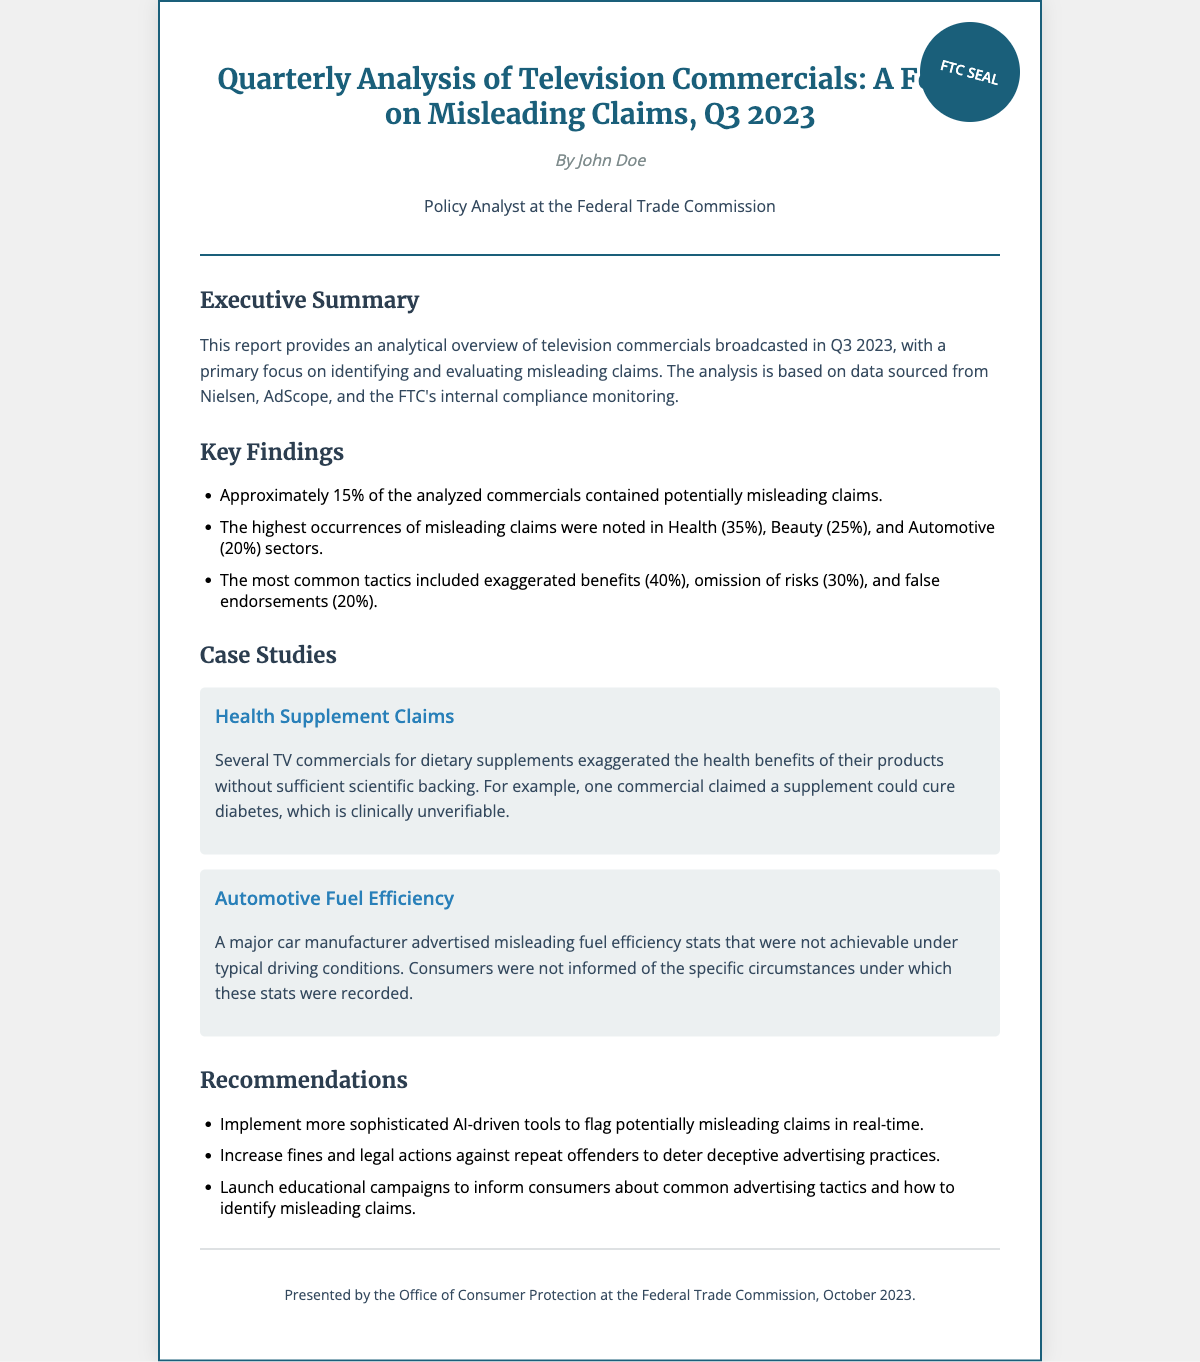what percentage of commercials contained potentially misleading claims? The report states that approximately 15% of the analyzed commercials contained potentially misleading claims.
Answer: 15% which sector had the highest occurrence of misleading claims? The analysis found that the Health sector had the highest occurrences of misleading claims at 35%.
Answer: Health what tactic was most commonly used in misleading advertisements? The document notes that exaggerated benefits were the most common tactic, accounting for 40% of misleading claims.
Answer: Exaggerated benefits how many case studies are presented in the report? The document features two case studies regarding misleading claims in commercials.
Answer: Two who is the author of the report? The report is authored by John Doe, a Policy Analyst at the Federal Trade Commission.
Answer: John Doe what is one recommendation made in the report? One recommendation suggests implementing more sophisticated AI-driven tools to flag potentially misleading claims in real-time.
Answer: AI-driven tools what type of advertising claims were analyzed? The report focuses on television commercials, particularly highlighting misleading claims.
Answer: Television commercials when was the report presented? The report was presented in October 2023, as specified in the footer.
Answer: October 2023 